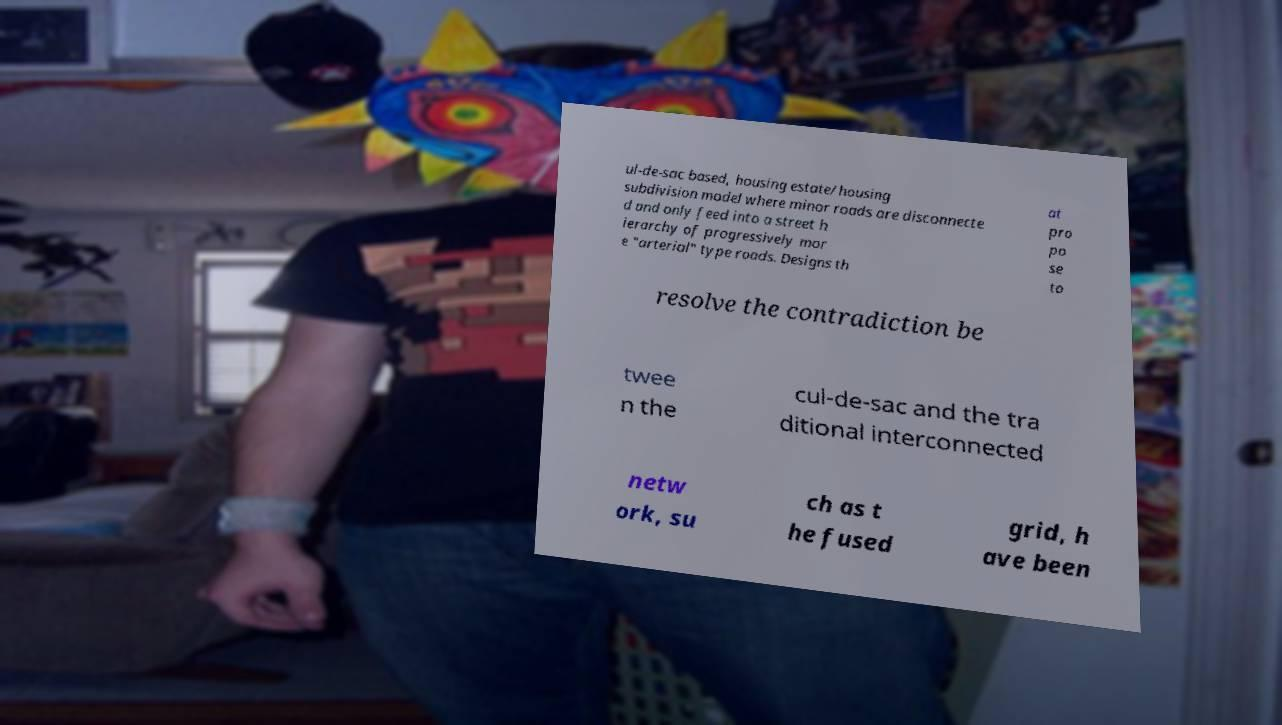Please read and relay the text visible in this image. What does it say? ul-de-sac based, housing estate/housing subdivision model where minor roads are disconnecte d and only feed into a street h ierarchy of progressively mor e "arterial" type roads. Designs th at pro po se to resolve the contradiction be twee n the cul-de-sac and the tra ditional interconnected netw ork, su ch as t he fused grid, h ave been 